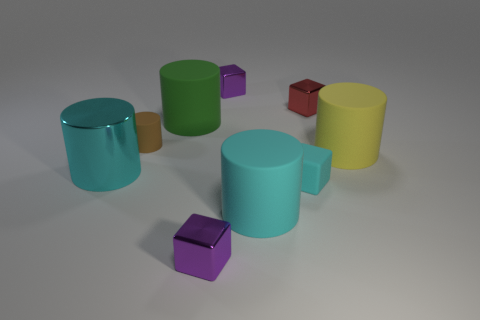How many purple blocks must be subtracted to get 1 purple blocks? 1 Subtract all tiny matte blocks. How many blocks are left? 3 Subtract all cylinders. How many objects are left? 4 Subtract 1 blocks. How many blocks are left? 3 Subtract all red blocks. Subtract all brown spheres. How many blocks are left? 3 Subtract all purple cubes. How many gray cylinders are left? 0 Subtract all small brown matte things. Subtract all big cyan rubber objects. How many objects are left? 7 Add 6 small cyan cubes. How many small cyan cubes are left? 7 Add 5 small brown cylinders. How many small brown cylinders exist? 6 Add 1 large cyan shiny cubes. How many objects exist? 10 